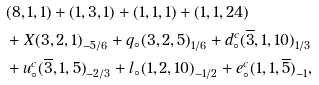Convert formula to latex. <formula><loc_0><loc_0><loc_500><loc_500>& { ( 8 , 1 , 1 ) + ( 1 , 3 , 1 ) + ( 1 , 1 , 1 ) + ( 1 , 1 , 2 4 ) } \\ & + X { ( 3 , 2 , 1 ) } _ { - 5 / 6 } + q _ { \circ } { ( 3 , 2 , 5 ) } _ { 1 / 6 } + d ^ { c } _ { \circ } { ( \overline { 3 } , 1 , 1 0 ) } _ { 1 / 3 } \\ & + u ^ { c } _ { \circ } { ( \overline { 3 } , 1 , 5 ) } _ { - 2 / 3 } + l _ { \circ } { ( 1 , 2 , 1 0 ) } _ { - 1 / 2 } + e ^ { c } _ { \circ } { ( 1 , 1 , \overline { 5 } ) } _ { - 1 } ,</formula> 